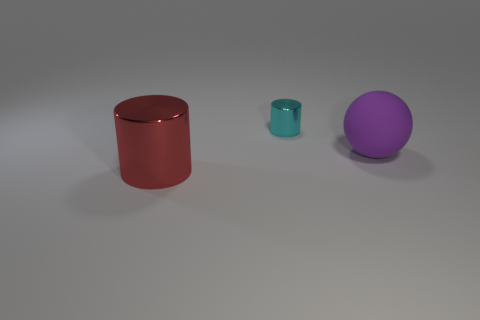Add 1 metallic cylinders. How many objects exist? 4 Subtract all cylinders. How many objects are left? 1 Subtract all small green spheres. Subtract all metal things. How many objects are left? 1 Add 2 big things. How many big things are left? 4 Add 1 large gray matte objects. How many large gray matte objects exist? 1 Subtract 0 green cylinders. How many objects are left? 3 